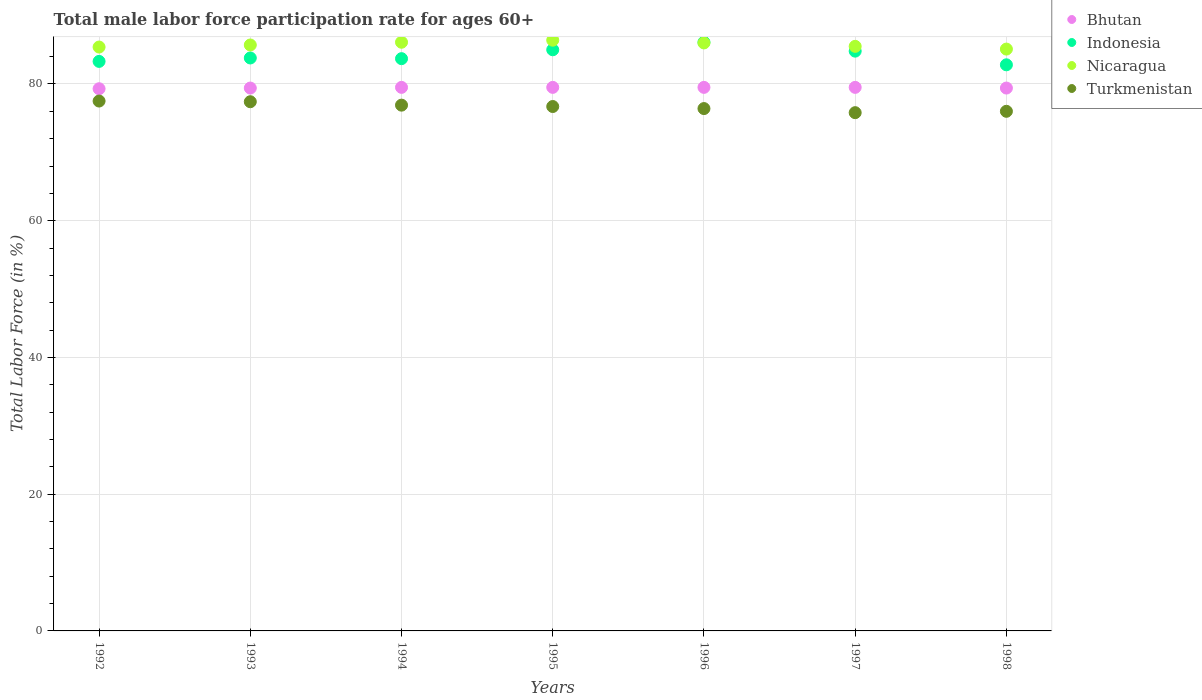How many different coloured dotlines are there?
Your answer should be compact. 4. What is the male labor force participation rate in Nicaragua in 1997?
Offer a terse response. 85.5. Across all years, what is the maximum male labor force participation rate in Indonesia?
Your response must be concise. 86.1. Across all years, what is the minimum male labor force participation rate in Nicaragua?
Offer a very short reply. 85.1. In which year was the male labor force participation rate in Nicaragua maximum?
Keep it short and to the point. 1995. In which year was the male labor force participation rate in Indonesia minimum?
Keep it short and to the point. 1998. What is the total male labor force participation rate in Indonesia in the graph?
Give a very brief answer. 589.5. What is the difference between the male labor force participation rate in Indonesia in 1994 and that in 1996?
Give a very brief answer. -2.4. What is the difference between the male labor force participation rate in Bhutan in 1992 and the male labor force participation rate in Indonesia in 1994?
Your answer should be very brief. -4.4. What is the average male labor force participation rate in Nicaragua per year?
Provide a succinct answer. 85.74. In the year 1996, what is the difference between the male labor force participation rate in Turkmenistan and male labor force participation rate in Indonesia?
Your response must be concise. -9.7. In how many years, is the male labor force participation rate in Indonesia greater than 8 %?
Your response must be concise. 7. What is the ratio of the male labor force participation rate in Bhutan in 1992 to that in 1994?
Your answer should be very brief. 1. Is the male labor force participation rate in Turkmenistan in 1996 less than that in 1998?
Your answer should be compact. No. Is the difference between the male labor force participation rate in Turkmenistan in 1993 and 1997 greater than the difference between the male labor force participation rate in Indonesia in 1993 and 1997?
Your response must be concise. Yes. What is the difference between the highest and the second highest male labor force participation rate in Indonesia?
Your answer should be compact. 1.1. What is the difference between the highest and the lowest male labor force participation rate in Bhutan?
Your answer should be very brief. 0.2. What is the difference between two consecutive major ticks on the Y-axis?
Your answer should be very brief. 20. Are the values on the major ticks of Y-axis written in scientific E-notation?
Ensure brevity in your answer.  No. Does the graph contain grids?
Make the answer very short. Yes. Where does the legend appear in the graph?
Provide a succinct answer. Top right. How many legend labels are there?
Keep it short and to the point. 4. How are the legend labels stacked?
Ensure brevity in your answer.  Vertical. What is the title of the graph?
Your answer should be compact. Total male labor force participation rate for ages 60+. What is the label or title of the Y-axis?
Make the answer very short. Total Labor Force (in %). What is the Total Labor Force (in %) of Bhutan in 1992?
Your response must be concise. 79.3. What is the Total Labor Force (in %) of Indonesia in 1992?
Offer a very short reply. 83.3. What is the Total Labor Force (in %) in Nicaragua in 1992?
Keep it short and to the point. 85.4. What is the Total Labor Force (in %) in Turkmenistan in 1992?
Keep it short and to the point. 77.5. What is the Total Labor Force (in %) in Bhutan in 1993?
Provide a short and direct response. 79.4. What is the Total Labor Force (in %) in Indonesia in 1993?
Offer a very short reply. 83.8. What is the Total Labor Force (in %) of Nicaragua in 1993?
Provide a succinct answer. 85.7. What is the Total Labor Force (in %) in Turkmenistan in 1993?
Your response must be concise. 77.4. What is the Total Labor Force (in %) in Bhutan in 1994?
Provide a succinct answer. 79.5. What is the Total Labor Force (in %) in Indonesia in 1994?
Offer a terse response. 83.7. What is the Total Labor Force (in %) in Nicaragua in 1994?
Your answer should be compact. 86.1. What is the Total Labor Force (in %) of Turkmenistan in 1994?
Your response must be concise. 76.9. What is the Total Labor Force (in %) of Bhutan in 1995?
Ensure brevity in your answer.  79.5. What is the Total Labor Force (in %) of Nicaragua in 1995?
Make the answer very short. 86.4. What is the Total Labor Force (in %) of Turkmenistan in 1995?
Keep it short and to the point. 76.7. What is the Total Labor Force (in %) in Bhutan in 1996?
Your answer should be compact. 79.5. What is the Total Labor Force (in %) of Indonesia in 1996?
Keep it short and to the point. 86.1. What is the Total Labor Force (in %) in Nicaragua in 1996?
Offer a terse response. 86. What is the Total Labor Force (in %) in Turkmenistan in 1996?
Your answer should be compact. 76.4. What is the Total Labor Force (in %) in Bhutan in 1997?
Your response must be concise. 79.5. What is the Total Labor Force (in %) of Indonesia in 1997?
Your answer should be compact. 84.8. What is the Total Labor Force (in %) in Nicaragua in 1997?
Offer a terse response. 85.5. What is the Total Labor Force (in %) in Turkmenistan in 1997?
Ensure brevity in your answer.  75.8. What is the Total Labor Force (in %) of Bhutan in 1998?
Ensure brevity in your answer.  79.4. What is the Total Labor Force (in %) of Indonesia in 1998?
Provide a short and direct response. 82.8. What is the Total Labor Force (in %) in Nicaragua in 1998?
Offer a terse response. 85.1. What is the Total Labor Force (in %) in Turkmenistan in 1998?
Your answer should be very brief. 76. Across all years, what is the maximum Total Labor Force (in %) of Bhutan?
Your answer should be compact. 79.5. Across all years, what is the maximum Total Labor Force (in %) of Indonesia?
Provide a succinct answer. 86.1. Across all years, what is the maximum Total Labor Force (in %) of Nicaragua?
Ensure brevity in your answer.  86.4. Across all years, what is the maximum Total Labor Force (in %) in Turkmenistan?
Your answer should be very brief. 77.5. Across all years, what is the minimum Total Labor Force (in %) in Bhutan?
Your answer should be compact. 79.3. Across all years, what is the minimum Total Labor Force (in %) in Indonesia?
Ensure brevity in your answer.  82.8. Across all years, what is the minimum Total Labor Force (in %) of Nicaragua?
Offer a terse response. 85.1. Across all years, what is the minimum Total Labor Force (in %) of Turkmenistan?
Keep it short and to the point. 75.8. What is the total Total Labor Force (in %) in Bhutan in the graph?
Provide a short and direct response. 556.1. What is the total Total Labor Force (in %) of Indonesia in the graph?
Your answer should be very brief. 589.5. What is the total Total Labor Force (in %) of Nicaragua in the graph?
Keep it short and to the point. 600.2. What is the total Total Labor Force (in %) in Turkmenistan in the graph?
Offer a terse response. 536.7. What is the difference between the Total Labor Force (in %) of Bhutan in 1992 and that in 1993?
Your response must be concise. -0.1. What is the difference between the Total Labor Force (in %) of Nicaragua in 1992 and that in 1993?
Your answer should be compact. -0.3. What is the difference between the Total Labor Force (in %) in Indonesia in 1992 and that in 1994?
Your answer should be compact. -0.4. What is the difference between the Total Labor Force (in %) of Nicaragua in 1992 and that in 1994?
Offer a terse response. -0.7. What is the difference between the Total Labor Force (in %) of Bhutan in 1992 and that in 1995?
Keep it short and to the point. -0.2. What is the difference between the Total Labor Force (in %) of Indonesia in 1992 and that in 1995?
Offer a very short reply. -1.7. What is the difference between the Total Labor Force (in %) in Nicaragua in 1992 and that in 1995?
Your response must be concise. -1. What is the difference between the Total Labor Force (in %) in Turkmenistan in 1992 and that in 1995?
Keep it short and to the point. 0.8. What is the difference between the Total Labor Force (in %) of Indonesia in 1992 and that in 1996?
Your answer should be very brief. -2.8. What is the difference between the Total Labor Force (in %) in Turkmenistan in 1992 and that in 1996?
Provide a short and direct response. 1.1. What is the difference between the Total Labor Force (in %) of Bhutan in 1992 and that in 1997?
Ensure brevity in your answer.  -0.2. What is the difference between the Total Labor Force (in %) in Indonesia in 1992 and that in 1997?
Give a very brief answer. -1.5. What is the difference between the Total Labor Force (in %) of Nicaragua in 1992 and that in 1997?
Provide a succinct answer. -0.1. What is the difference between the Total Labor Force (in %) in Bhutan in 1992 and that in 1998?
Offer a terse response. -0.1. What is the difference between the Total Labor Force (in %) in Indonesia in 1992 and that in 1998?
Your answer should be compact. 0.5. What is the difference between the Total Labor Force (in %) in Nicaragua in 1992 and that in 1998?
Your answer should be very brief. 0.3. What is the difference between the Total Labor Force (in %) of Turkmenistan in 1992 and that in 1998?
Ensure brevity in your answer.  1.5. What is the difference between the Total Labor Force (in %) in Bhutan in 1993 and that in 1994?
Ensure brevity in your answer.  -0.1. What is the difference between the Total Labor Force (in %) in Indonesia in 1993 and that in 1994?
Your response must be concise. 0.1. What is the difference between the Total Labor Force (in %) of Nicaragua in 1993 and that in 1994?
Provide a short and direct response. -0.4. What is the difference between the Total Labor Force (in %) of Nicaragua in 1993 and that in 1995?
Provide a short and direct response. -0.7. What is the difference between the Total Labor Force (in %) of Turkmenistan in 1993 and that in 1995?
Your answer should be compact. 0.7. What is the difference between the Total Labor Force (in %) in Indonesia in 1993 and that in 1996?
Make the answer very short. -2.3. What is the difference between the Total Labor Force (in %) in Nicaragua in 1993 and that in 1996?
Give a very brief answer. -0.3. What is the difference between the Total Labor Force (in %) of Turkmenistan in 1993 and that in 1996?
Give a very brief answer. 1. What is the difference between the Total Labor Force (in %) of Indonesia in 1993 and that in 1997?
Provide a short and direct response. -1. What is the difference between the Total Labor Force (in %) in Turkmenistan in 1993 and that in 1997?
Offer a very short reply. 1.6. What is the difference between the Total Labor Force (in %) in Indonesia in 1993 and that in 1998?
Make the answer very short. 1. What is the difference between the Total Labor Force (in %) of Bhutan in 1994 and that in 1995?
Offer a very short reply. 0. What is the difference between the Total Labor Force (in %) of Indonesia in 1994 and that in 1995?
Make the answer very short. -1.3. What is the difference between the Total Labor Force (in %) of Nicaragua in 1994 and that in 1995?
Ensure brevity in your answer.  -0.3. What is the difference between the Total Labor Force (in %) in Turkmenistan in 1994 and that in 1995?
Your response must be concise. 0.2. What is the difference between the Total Labor Force (in %) of Nicaragua in 1994 and that in 1996?
Offer a very short reply. 0.1. What is the difference between the Total Labor Force (in %) of Bhutan in 1994 and that in 1997?
Provide a succinct answer. 0. What is the difference between the Total Labor Force (in %) of Indonesia in 1994 and that in 1997?
Ensure brevity in your answer.  -1.1. What is the difference between the Total Labor Force (in %) in Turkmenistan in 1994 and that in 1997?
Ensure brevity in your answer.  1.1. What is the difference between the Total Labor Force (in %) of Bhutan in 1994 and that in 1998?
Your answer should be very brief. 0.1. What is the difference between the Total Labor Force (in %) of Bhutan in 1995 and that in 1996?
Make the answer very short. 0. What is the difference between the Total Labor Force (in %) in Indonesia in 1995 and that in 1996?
Your response must be concise. -1.1. What is the difference between the Total Labor Force (in %) in Bhutan in 1995 and that in 1997?
Give a very brief answer. 0. What is the difference between the Total Labor Force (in %) in Turkmenistan in 1995 and that in 1997?
Keep it short and to the point. 0.9. What is the difference between the Total Labor Force (in %) of Bhutan in 1995 and that in 1998?
Ensure brevity in your answer.  0.1. What is the difference between the Total Labor Force (in %) in Indonesia in 1995 and that in 1998?
Your answer should be very brief. 2.2. What is the difference between the Total Labor Force (in %) in Nicaragua in 1995 and that in 1998?
Provide a short and direct response. 1.3. What is the difference between the Total Labor Force (in %) of Turkmenistan in 1995 and that in 1998?
Your answer should be compact. 0.7. What is the difference between the Total Labor Force (in %) of Bhutan in 1996 and that in 1997?
Give a very brief answer. 0. What is the difference between the Total Labor Force (in %) of Nicaragua in 1996 and that in 1997?
Offer a terse response. 0.5. What is the difference between the Total Labor Force (in %) of Turkmenistan in 1996 and that in 1997?
Your answer should be very brief. 0.6. What is the difference between the Total Labor Force (in %) of Bhutan in 1996 and that in 1998?
Provide a short and direct response. 0.1. What is the difference between the Total Labor Force (in %) in Indonesia in 1996 and that in 1998?
Provide a succinct answer. 3.3. What is the difference between the Total Labor Force (in %) of Nicaragua in 1996 and that in 1998?
Offer a very short reply. 0.9. What is the difference between the Total Labor Force (in %) of Indonesia in 1997 and that in 1998?
Your response must be concise. 2. What is the difference between the Total Labor Force (in %) in Turkmenistan in 1997 and that in 1998?
Your answer should be very brief. -0.2. What is the difference between the Total Labor Force (in %) in Bhutan in 1992 and the Total Labor Force (in %) in Indonesia in 1993?
Keep it short and to the point. -4.5. What is the difference between the Total Labor Force (in %) in Indonesia in 1992 and the Total Labor Force (in %) in Nicaragua in 1993?
Provide a succinct answer. -2.4. What is the difference between the Total Labor Force (in %) in Indonesia in 1992 and the Total Labor Force (in %) in Turkmenistan in 1993?
Make the answer very short. 5.9. What is the difference between the Total Labor Force (in %) of Nicaragua in 1992 and the Total Labor Force (in %) of Turkmenistan in 1993?
Offer a very short reply. 8. What is the difference between the Total Labor Force (in %) of Bhutan in 1992 and the Total Labor Force (in %) of Indonesia in 1994?
Provide a succinct answer. -4.4. What is the difference between the Total Labor Force (in %) of Bhutan in 1992 and the Total Labor Force (in %) of Nicaragua in 1994?
Your answer should be compact. -6.8. What is the difference between the Total Labor Force (in %) of Bhutan in 1992 and the Total Labor Force (in %) of Turkmenistan in 1994?
Your answer should be very brief. 2.4. What is the difference between the Total Labor Force (in %) in Indonesia in 1992 and the Total Labor Force (in %) in Nicaragua in 1994?
Provide a succinct answer. -2.8. What is the difference between the Total Labor Force (in %) of Indonesia in 1992 and the Total Labor Force (in %) of Turkmenistan in 1994?
Give a very brief answer. 6.4. What is the difference between the Total Labor Force (in %) of Bhutan in 1992 and the Total Labor Force (in %) of Indonesia in 1995?
Make the answer very short. -5.7. What is the difference between the Total Labor Force (in %) in Bhutan in 1992 and the Total Labor Force (in %) in Turkmenistan in 1995?
Provide a short and direct response. 2.6. What is the difference between the Total Labor Force (in %) of Indonesia in 1992 and the Total Labor Force (in %) of Nicaragua in 1995?
Your response must be concise. -3.1. What is the difference between the Total Labor Force (in %) of Bhutan in 1992 and the Total Labor Force (in %) of Indonesia in 1996?
Ensure brevity in your answer.  -6.8. What is the difference between the Total Labor Force (in %) of Indonesia in 1992 and the Total Labor Force (in %) of Turkmenistan in 1996?
Make the answer very short. 6.9. What is the difference between the Total Labor Force (in %) in Nicaragua in 1992 and the Total Labor Force (in %) in Turkmenistan in 1996?
Your answer should be very brief. 9. What is the difference between the Total Labor Force (in %) of Bhutan in 1992 and the Total Labor Force (in %) of Indonesia in 1997?
Your answer should be compact. -5.5. What is the difference between the Total Labor Force (in %) of Indonesia in 1992 and the Total Labor Force (in %) of Turkmenistan in 1997?
Your response must be concise. 7.5. What is the difference between the Total Labor Force (in %) of Bhutan in 1992 and the Total Labor Force (in %) of Indonesia in 1998?
Your answer should be compact. -3.5. What is the difference between the Total Labor Force (in %) in Bhutan in 1992 and the Total Labor Force (in %) in Turkmenistan in 1998?
Your response must be concise. 3.3. What is the difference between the Total Labor Force (in %) in Indonesia in 1992 and the Total Labor Force (in %) in Nicaragua in 1998?
Offer a terse response. -1.8. What is the difference between the Total Labor Force (in %) of Nicaragua in 1992 and the Total Labor Force (in %) of Turkmenistan in 1998?
Ensure brevity in your answer.  9.4. What is the difference between the Total Labor Force (in %) in Bhutan in 1993 and the Total Labor Force (in %) in Turkmenistan in 1994?
Give a very brief answer. 2.5. What is the difference between the Total Labor Force (in %) of Indonesia in 1993 and the Total Labor Force (in %) of Turkmenistan in 1994?
Your answer should be very brief. 6.9. What is the difference between the Total Labor Force (in %) in Bhutan in 1993 and the Total Labor Force (in %) in Indonesia in 1995?
Provide a succinct answer. -5.6. What is the difference between the Total Labor Force (in %) in Indonesia in 1993 and the Total Labor Force (in %) in Nicaragua in 1995?
Make the answer very short. -2.6. What is the difference between the Total Labor Force (in %) in Indonesia in 1993 and the Total Labor Force (in %) in Turkmenistan in 1995?
Make the answer very short. 7.1. What is the difference between the Total Labor Force (in %) in Nicaragua in 1993 and the Total Labor Force (in %) in Turkmenistan in 1995?
Provide a succinct answer. 9. What is the difference between the Total Labor Force (in %) in Bhutan in 1993 and the Total Labor Force (in %) in Nicaragua in 1996?
Your answer should be compact. -6.6. What is the difference between the Total Labor Force (in %) in Bhutan in 1993 and the Total Labor Force (in %) in Turkmenistan in 1996?
Offer a very short reply. 3. What is the difference between the Total Labor Force (in %) in Indonesia in 1993 and the Total Labor Force (in %) in Nicaragua in 1996?
Make the answer very short. -2.2. What is the difference between the Total Labor Force (in %) in Nicaragua in 1993 and the Total Labor Force (in %) in Turkmenistan in 1996?
Your answer should be compact. 9.3. What is the difference between the Total Labor Force (in %) in Bhutan in 1993 and the Total Labor Force (in %) in Indonesia in 1997?
Offer a very short reply. -5.4. What is the difference between the Total Labor Force (in %) in Bhutan in 1993 and the Total Labor Force (in %) in Turkmenistan in 1997?
Your answer should be very brief. 3.6. What is the difference between the Total Labor Force (in %) in Indonesia in 1993 and the Total Labor Force (in %) in Nicaragua in 1997?
Make the answer very short. -1.7. What is the difference between the Total Labor Force (in %) in Indonesia in 1993 and the Total Labor Force (in %) in Turkmenistan in 1997?
Make the answer very short. 8. What is the difference between the Total Labor Force (in %) in Bhutan in 1993 and the Total Labor Force (in %) in Nicaragua in 1998?
Make the answer very short. -5.7. What is the difference between the Total Labor Force (in %) in Indonesia in 1993 and the Total Labor Force (in %) in Turkmenistan in 1998?
Your answer should be compact. 7.8. What is the difference between the Total Labor Force (in %) in Nicaragua in 1993 and the Total Labor Force (in %) in Turkmenistan in 1998?
Make the answer very short. 9.7. What is the difference between the Total Labor Force (in %) in Bhutan in 1994 and the Total Labor Force (in %) in Indonesia in 1995?
Make the answer very short. -5.5. What is the difference between the Total Labor Force (in %) in Bhutan in 1994 and the Total Labor Force (in %) in Nicaragua in 1995?
Offer a very short reply. -6.9. What is the difference between the Total Labor Force (in %) of Bhutan in 1994 and the Total Labor Force (in %) of Turkmenistan in 1995?
Your response must be concise. 2.8. What is the difference between the Total Labor Force (in %) of Indonesia in 1994 and the Total Labor Force (in %) of Turkmenistan in 1995?
Provide a short and direct response. 7. What is the difference between the Total Labor Force (in %) in Nicaragua in 1994 and the Total Labor Force (in %) in Turkmenistan in 1995?
Your answer should be compact. 9.4. What is the difference between the Total Labor Force (in %) of Bhutan in 1994 and the Total Labor Force (in %) of Indonesia in 1996?
Your response must be concise. -6.6. What is the difference between the Total Labor Force (in %) in Bhutan in 1994 and the Total Labor Force (in %) in Turkmenistan in 1996?
Your answer should be very brief. 3.1. What is the difference between the Total Labor Force (in %) of Indonesia in 1994 and the Total Labor Force (in %) of Nicaragua in 1996?
Offer a terse response. -2.3. What is the difference between the Total Labor Force (in %) of Indonesia in 1994 and the Total Labor Force (in %) of Turkmenistan in 1996?
Offer a very short reply. 7.3. What is the difference between the Total Labor Force (in %) in Nicaragua in 1994 and the Total Labor Force (in %) in Turkmenistan in 1996?
Ensure brevity in your answer.  9.7. What is the difference between the Total Labor Force (in %) in Bhutan in 1994 and the Total Labor Force (in %) in Nicaragua in 1997?
Your answer should be very brief. -6. What is the difference between the Total Labor Force (in %) of Bhutan in 1994 and the Total Labor Force (in %) of Turkmenistan in 1997?
Provide a succinct answer. 3.7. What is the difference between the Total Labor Force (in %) in Indonesia in 1994 and the Total Labor Force (in %) in Nicaragua in 1997?
Your answer should be compact. -1.8. What is the difference between the Total Labor Force (in %) of Indonesia in 1994 and the Total Labor Force (in %) of Turkmenistan in 1997?
Your answer should be compact. 7.9. What is the difference between the Total Labor Force (in %) of Nicaragua in 1994 and the Total Labor Force (in %) of Turkmenistan in 1997?
Provide a short and direct response. 10.3. What is the difference between the Total Labor Force (in %) of Bhutan in 1994 and the Total Labor Force (in %) of Indonesia in 1998?
Provide a short and direct response. -3.3. What is the difference between the Total Labor Force (in %) of Bhutan in 1994 and the Total Labor Force (in %) of Nicaragua in 1998?
Ensure brevity in your answer.  -5.6. What is the difference between the Total Labor Force (in %) in Indonesia in 1994 and the Total Labor Force (in %) in Nicaragua in 1998?
Keep it short and to the point. -1.4. What is the difference between the Total Labor Force (in %) in Indonesia in 1994 and the Total Labor Force (in %) in Turkmenistan in 1998?
Your answer should be compact. 7.7. What is the difference between the Total Labor Force (in %) of Nicaragua in 1994 and the Total Labor Force (in %) of Turkmenistan in 1998?
Give a very brief answer. 10.1. What is the difference between the Total Labor Force (in %) in Bhutan in 1995 and the Total Labor Force (in %) in Indonesia in 1996?
Offer a very short reply. -6.6. What is the difference between the Total Labor Force (in %) in Indonesia in 1995 and the Total Labor Force (in %) in Turkmenistan in 1996?
Your response must be concise. 8.6. What is the difference between the Total Labor Force (in %) in Bhutan in 1995 and the Total Labor Force (in %) in Nicaragua in 1997?
Offer a very short reply. -6. What is the difference between the Total Labor Force (in %) of Bhutan in 1995 and the Total Labor Force (in %) of Turkmenistan in 1997?
Provide a short and direct response. 3.7. What is the difference between the Total Labor Force (in %) of Indonesia in 1995 and the Total Labor Force (in %) of Nicaragua in 1997?
Provide a succinct answer. -0.5. What is the difference between the Total Labor Force (in %) in Nicaragua in 1995 and the Total Labor Force (in %) in Turkmenistan in 1997?
Your response must be concise. 10.6. What is the difference between the Total Labor Force (in %) of Indonesia in 1995 and the Total Labor Force (in %) of Turkmenistan in 1998?
Your response must be concise. 9. What is the difference between the Total Labor Force (in %) of Nicaragua in 1995 and the Total Labor Force (in %) of Turkmenistan in 1998?
Provide a succinct answer. 10.4. What is the difference between the Total Labor Force (in %) in Bhutan in 1996 and the Total Labor Force (in %) in Turkmenistan in 1997?
Ensure brevity in your answer.  3.7. What is the difference between the Total Labor Force (in %) in Indonesia in 1996 and the Total Labor Force (in %) in Nicaragua in 1997?
Your answer should be compact. 0.6. What is the difference between the Total Labor Force (in %) of Bhutan in 1996 and the Total Labor Force (in %) of Nicaragua in 1998?
Keep it short and to the point. -5.6. What is the difference between the Total Labor Force (in %) in Bhutan in 1996 and the Total Labor Force (in %) in Turkmenistan in 1998?
Ensure brevity in your answer.  3.5. What is the difference between the Total Labor Force (in %) in Indonesia in 1996 and the Total Labor Force (in %) in Nicaragua in 1998?
Offer a terse response. 1. What is the difference between the Total Labor Force (in %) of Indonesia in 1996 and the Total Labor Force (in %) of Turkmenistan in 1998?
Give a very brief answer. 10.1. What is the difference between the Total Labor Force (in %) in Bhutan in 1997 and the Total Labor Force (in %) in Nicaragua in 1998?
Your response must be concise. -5.6. What is the difference between the Total Labor Force (in %) in Indonesia in 1997 and the Total Labor Force (in %) in Nicaragua in 1998?
Make the answer very short. -0.3. What is the average Total Labor Force (in %) in Bhutan per year?
Keep it short and to the point. 79.44. What is the average Total Labor Force (in %) of Indonesia per year?
Provide a short and direct response. 84.21. What is the average Total Labor Force (in %) in Nicaragua per year?
Your response must be concise. 85.74. What is the average Total Labor Force (in %) in Turkmenistan per year?
Offer a terse response. 76.67. In the year 1992, what is the difference between the Total Labor Force (in %) in Bhutan and Total Labor Force (in %) in Indonesia?
Provide a short and direct response. -4. In the year 1992, what is the difference between the Total Labor Force (in %) of Bhutan and Total Labor Force (in %) of Nicaragua?
Give a very brief answer. -6.1. In the year 1992, what is the difference between the Total Labor Force (in %) of Bhutan and Total Labor Force (in %) of Turkmenistan?
Offer a terse response. 1.8. In the year 1992, what is the difference between the Total Labor Force (in %) of Indonesia and Total Labor Force (in %) of Turkmenistan?
Offer a very short reply. 5.8. In the year 1993, what is the difference between the Total Labor Force (in %) of Bhutan and Total Labor Force (in %) of Nicaragua?
Your answer should be very brief. -6.3. In the year 1993, what is the difference between the Total Labor Force (in %) in Indonesia and Total Labor Force (in %) in Turkmenistan?
Make the answer very short. 6.4. In the year 1994, what is the difference between the Total Labor Force (in %) in Bhutan and Total Labor Force (in %) in Nicaragua?
Provide a short and direct response. -6.6. In the year 1994, what is the difference between the Total Labor Force (in %) in Nicaragua and Total Labor Force (in %) in Turkmenistan?
Keep it short and to the point. 9.2. In the year 1995, what is the difference between the Total Labor Force (in %) of Bhutan and Total Labor Force (in %) of Indonesia?
Your answer should be compact. -5.5. In the year 1995, what is the difference between the Total Labor Force (in %) in Bhutan and Total Labor Force (in %) in Nicaragua?
Your response must be concise. -6.9. In the year 1995, what is the difference between the Total Labor Force (in %) in Indonesia and Total Labor Force (in %) in Nicaragua?
Keep it short and to the point. -1.4. In the year 1996, what is the difference between the Total Labor Force (in %) of Bhutan and Total Labor Force (in %) of Indonesia?
Provide a short and direct response. -6.6. In the year 1996, what is the difference between the Total Labor Force (in %) of Bhutan and Total Labor Force (in %) of Turkmenistan?
Keep it short and to the point. 3.1. In the year 1996, what is the difference between the Total Labor Force (in %) of Indonesia and Total Labor Force (in %) of Nicaragua?
Keep it short and to the point. 0.1. In the year 1996, what is the difference between the Total Labor Force (in %) of Indonesia and Total Labor Force (in %) of Turkmenistan?
Make the answer very short. 9.7. In the year 1996, what is the difference between the Total Labor Force (in %) in Nicaragua and Total Labor Force (in %) in Turkmenistan?
Make the answer very short. 9.6. In the year 1997, what is the difference between the Total Labor Force (in %) in Bhutan and Total Labor Force (in %) in Indonesia?
Your answer should be compact. -5.3. In the year 1997, what is the difference between the Total Labor Force (in %) in Bhutan and Total Labor Force (in %) in Turkmenistan?
Offer a very short reply. 3.7. In the year 1997, what is the difference between the Total Labor Force (in %) in Indonesia and Total Labor Force (in %) in Turkmenistan?
Your answer should be compact. 9. In the year 1997, what is the difference between the Total Labor Force (in %) in Nicaragua and Total Labor Force (in %) in Turkmenistan?
Make the answer very short. 9.7. In the year 1998, what is the difference between the Total Labor Force (in %) of Bhutan and Total Labor Force (in %) of Turkmenistan?
Provide a short and direct response. 3.4. In the year 1998, what is the difference between the Total Labor Force (in %) in Indonesia and Total Labor Force (in %) in Nicaragua?
Keep it short and to the point. -2.3. In the year 1998, what is the difference between the Total Labor Force (in %) of Nicaragua and Total Labor Force (in %) of Turkmenistan?
Your response must be concise. 9.1. What is the ratio of the Total Labor Force (in %) in Indonesia in 1992 to that in 1993?
Ensure brevity in your answer.  0.99. What is the ratio of the Total Labor Force (in %) of Nicaragua in 1992 to that in 1993?
Your answer should be compact. 1. What is the ratio of the Total Labor Force (in %) of Nicaragua in 1992 to that in 1994?
Your answer should be compact. 0.99. What is the ratio of the Total Labor Force (in %) in Turkmenistan in 1992 to that in 1994?
Your answer should be very brief. 1.01. What is the ratio of the Total Labor Force (in %) of Bhutan in 1992 to that in 1995?
Make the answer very short. 1. What is the ratio of the Total Labor Force (in %) in Indonesia in 1992 to that in 1995?
Offer a very short reply. 0.98. What is the ratio of the Total Labor Force (in %) in Nicaragua in 1992 to that in 1995?
Offer a very short reply. 0.99. What is the ratio of the Total Labor Force (in %) in Turkmenistan in 1992 to that in 1995?
Provide a short and direct response. 1.01. What is the ratio of the Total Labor Force (in %) in Indonesia in 1992 to that in 1996?
Keep it short and to the point. 0.97. What is the ratio of the Total Labor Force (in %) in Nicaragua in 1992 to that in 1996?
Make the answer very short. 0.99. What is the ratio of the Total Labor Force (in %) in Turkmenistan in 1992 to that in 1996?
Give a very brief answer. 1.01. What is the ratio of the Total Labor Force (in %) in Indonesia in 1992 to that in 1997?
Provide a short and direct response. 0.98. What is the ratio of the Total Labor Force (in %) of Nicaragua in 1992 to that in 1997?
Your response must be concise. 1. What is the ratio of the Total Labor Force (in %) of Turkmenistan in 1992 to that in 1997?
Your answer should be very brief. 1.02. What is the ratio of the Total Labor Force (in %) in Bhutan in 1992 to that in 1998?
Offer a very short reply. 1. What is the ratio of the Total Labor Force (in %) in Indonesia in 1992 to that in 1998?
Your response must be concise. 1.01. What is the ratio of the Total Labor Force (in %) of Nicaragua in 1992 to that in 1998?
Provide a short and direct response. 1. What is the ratio of the Total Labor Force (in %) in Turkmenistan in 1992 to that in 1998?
Your answer should be compact. 1.02. What is the ratio of the Total Labor Force (in %) in Nicaragua in 1993 to that in 1994?
Offer a very short reply. 1. What is the ratio of the Total Labor Force (in %) of Turkmenistan in 1993 to that in 1994?
Your response must be concise. 1.01. What is the ratio of the Total Labor Force (in %) in Indonesia in 1993 to that in 1995?
Ensure brevity in your answer.  0.99. What is the ratio of the Total Labor Force (in %) in Turkmenistan in 1993 to that in 1995?
Provide a succinct answer. 1.01. What is the ratio of the Total Labor Force (in %) in Bhutan in 1993 to that in 1996?
Keep it short and to the point. 1. What is the ratio of the Total Labor Force (in %) of Indonesia in 1993 to that in 1996?
Ensure brevity in your answer.  0.97. What is the ratio of the Total Labor Force (in %) in Nicaragua in 1993 to that in 1996?
Your response must be concise. 1. What is the ratio of the Total Labor Force (in %) of Turkmenistan in 1993 to that in 1996?
Your response must be concise. 1.01. What is the ratio of the Total Labor Force (in %) in Indonesia in 1993 to that in 1997?
Provide a short and direct response. 0.99. What is the ratio of the Total Labor Force (in %) of Turkmenistan in 1993 to that in 1997?
Provide a succinct answer. 1.02. What is the ratio of the Total Labor Force (in %) in Indonesia in 1993 to that in 1998?
Provide a succinct answer. 1.01. What is the ratio of the Total Labor Force (in %) in Nicaragua in 1993 to that in 1998?
Offer a very short reply. 1.01. What is the ratio of the Total Labor Force (in %) in Turkmenistan in 1993 to that in 1998?
Your answer should be very brief. 1.02. What is the ratio of the Total Labor Force (in %) in Bhutan in 1994 to that in 1995?
Give a very brief answer. 1. What is the ratio of the Total Labor Force (in %) in Indonesia in 1994 to that in 1995?
Provide a succinct answer. 0.98. What is the ratio of the Total Labor Force (in %) in Bhutan in 1994 to that in 1996?
Make the answer very short. 1. What is the ratio of the Total Labor Force (in %) of Indonesia in 1994 to that in 1996?
Keep it short and to the point. 0.97. What is the ratio of the Total Labor Force (in %) of Turkmenistan in 1994 to that in 1996?
Ensure brevity in your answer.  1.01. What is the ratio of the Total Labor Force (in %) of Indonesia in 1994 to that in 1997?
Give a very brief answer. 0.99. What is the ratio of the Total Labor Force (in %) in Turkmenistan in 1994 to that in 1997?
Ensure brevity in your answer.  1.01. What is the ratio of the Total Labor Force (in %) of Indonesia in 1994 to that in 1998?
Offer a very short reply. 1.01. What is the ratio of the Total Labor Force (in %) in Nicaragua in 1994 to that in 1998?
Give a very brief answer. 1.01. What is the ratio of the Total Labor Force (in %) in Turkmenistan in 1994 to that in 1998?
Offer a terse response. 1.01. What is the ratio of the Total Labor Force (in %) in Indonesia in 1995 to that in 1996?
Your answer should be compact. 0.99. What is the ratio of the Total Labor Force (in %) of Nicaragua in 1995 to that in 1996?
Your response must be concise. 1. What is the ratio of the Total Labor Force (in %) in Turkmenistan in 1995 to that in 1996?
Keep it short and to the point. 1. What is the ratio of the Total Labor Force (in %) of Nicaragua in 1995 to that in 1997?
Keep it short and to the point. 1.01. What is the ratio of the Total Labor Force (in %) of Turkmenistan in 1995 to that in 1997?
Keep it short and to the point. 1.01. What is the ratio of the Total Labor Force (in %) in Bhutan in 1995 to that in 1998?
Provide a succinct answer. 1. What is the ratio of the Total Labor Force (in %) of Indonesia in 1995 to that in 1998?
Provide a short and direct response. 1.03. What is the ratio of the Total Labor Force (in %) in Nicaragua in 1995 to that in 1998?
Offer a very short reply. 1.02. What is the ratio of the Total Labor Force (in %) in Turkmenistan in 1995 to that in 1998?
Make the answer very short. 1.01. What is the ratio of the Total Labor Force (in %) in Indonesia in 1996 to that in 1997?
Make the answer very short. 1.02. What is the ratio of the Total Labor Force (in %) in Turkmenistan in 1996 to that in 1997?
Your answer should be compact. 1.01. What is the ratio of the Total Labor Force (in %) of Indonesia in 1996 to that in 1998?
Keep it short and to the point. 1.04. What is the ratio of the Total Labor Force (in %) of Nicaragua in 1996 to that in 1998?
Your answer should be very brief. 1.01. What is the ratio of the Total Labor Force (in %) of Indonesia in 1997 to that in 1998?
Offer a very short reply. 1.02. What is the ratio of the Total Labor Force (in %) in Nicaragua in 1997 to that in 1998?
Ensure brevity in your answer.  1. What is the ratio of the Total Labor Force (in %) in Turkmenistan in 1997 to that in 1998?
Give a very brief answer. 1. What is the difference between the highest and the second highest Total Labor Force (in %) of Bhutan?
Give a very brief answer. 0. What is the difference between the highest and the second highest Total Labor Force (in %) of Indonesia?
Make the answer very short. 1.1. What is the difference between the highest and the second highest Total Labor Force (in %) of Nicaragua?
Make the answer very short. 0.3. What is the difference between the highest and the lowest Total Labor Force (in %) of Nicaragua?
Your response must be concise. 1.3. 